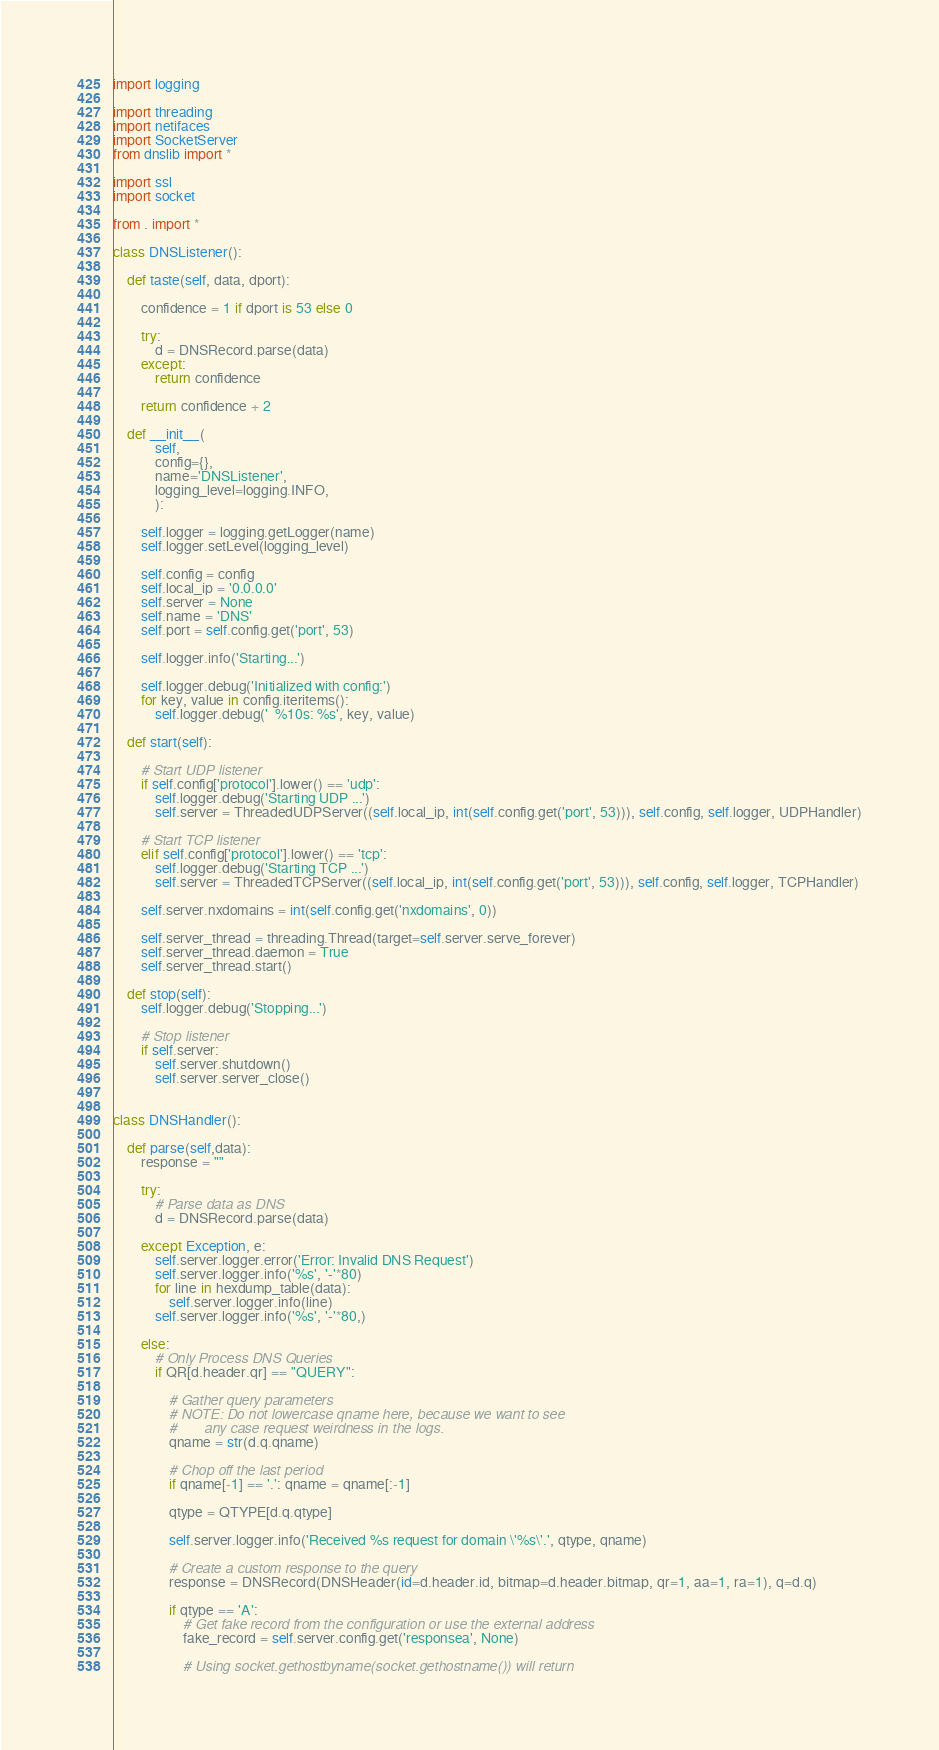<code> <loc_0><loc_0><loc_500><loc_500><_Python_>import logging

import threading
import netifaces
import SocketServer
from dnslib import *

import ssl
import socket

from . import *

class DNSListener():

    def taste(self, data, dport):

        confidence = 1 if dport is 53 else 0

        try:
            d = DNSRecord.parse(data)
        except:
            return confidence

        return confidence + 2

    def __init__(
            self, 
            config={}, 
            name='DNSListener', 
            logging_level=logging.INFO, 
            ):

        self.logger = logging.getLogger(name)
        self.logger.setLevel(logging_level)
            
        self.config = config
        self.local_ip = '0.0.0.0'
        self.server = None
        self.name = 'DNS'
        self.port = self.config.get('port', 53)

        self.logger.info('Starting...')

        self.logger.debug('Initialized with config:')
        for key, value in config.iteritems():
            self.logger.debug('  %10s: %s', key, value)

    def start(self):

        # Start UDP listener  
        if self.config['protocol'].lower() == 'udp':
            self.logger.debug('Starting UDP ...')
            self.server = ThreadedUDPServer((self.local_ip, int(self.config.get('port', 53))), self.config, self.logger, UDPHandler)

        # Start TCP listener
        elif self.config['protocol'].lower() == 'tcp':
            self.logger.debug('Starting TCP ...')
            self.server = ThreadedTCPServer((self.local_ip, int(self.config.get('port', 53))), self.config, self.logger, TCPHandler)

        self.server.nxdomains = int(self.config.get('nxdomains', 0))

        self.server_thread = threading.Thread(target=self.server.serve_forever)
        self.server_thread.daemon = True
        self.server_thread.start()

    def stop(self):
        self.logger.debug('Stopping...')
        
        # Stop listener
        if self.server:
            self.server.shutdown()
            self.server.server_close()  


class DNSHandler():
           
    def parse(self,data):
        response = ""
    
        try:
            # Parse data as DNS        
            d = DNSRecord.parse(data)

        except Exception, e:
            self.server.logger.error('Error: Invalid DNS Request')
            self.server.logger.info('%s', '-'*80)
            for line in hexdump_table(data):
                self.server.logger.info(line)
            self.server.logger.info('%s', '-'*80,)

        else:                 
            # Only Process DNS Queries
            if QR[d.header.qr] == "QUERY":
                     
                # Gather query parameters
                # NOTE: Do not lowercase qname here, because we want to see
                #       any case request weirdness in the logs.
                qname = str(d.q.qname)
                
                # Chop off the last period
                if qname[-1] == '.': qname = qname[:-1]

                qtype = QTYPE[d.q.qtype]

                self.server.logger.info('Received %s request for domain \'%s\'.', qtype, qname)

                # Create a custom response to the query
                response = DNSRecord(DNSHeader(id=d.header.id, bitmap=d.header.bitmap, qr=1, aa=1, ra=1), q=d.q)

                if qtype == 'A':
                    # Get fake record from the configuration or use the external address
                    fake_record = self.server.config.get('responsea', None)

                    # Using socket.gethostbyname(socket.gethostname()) will return</code> 